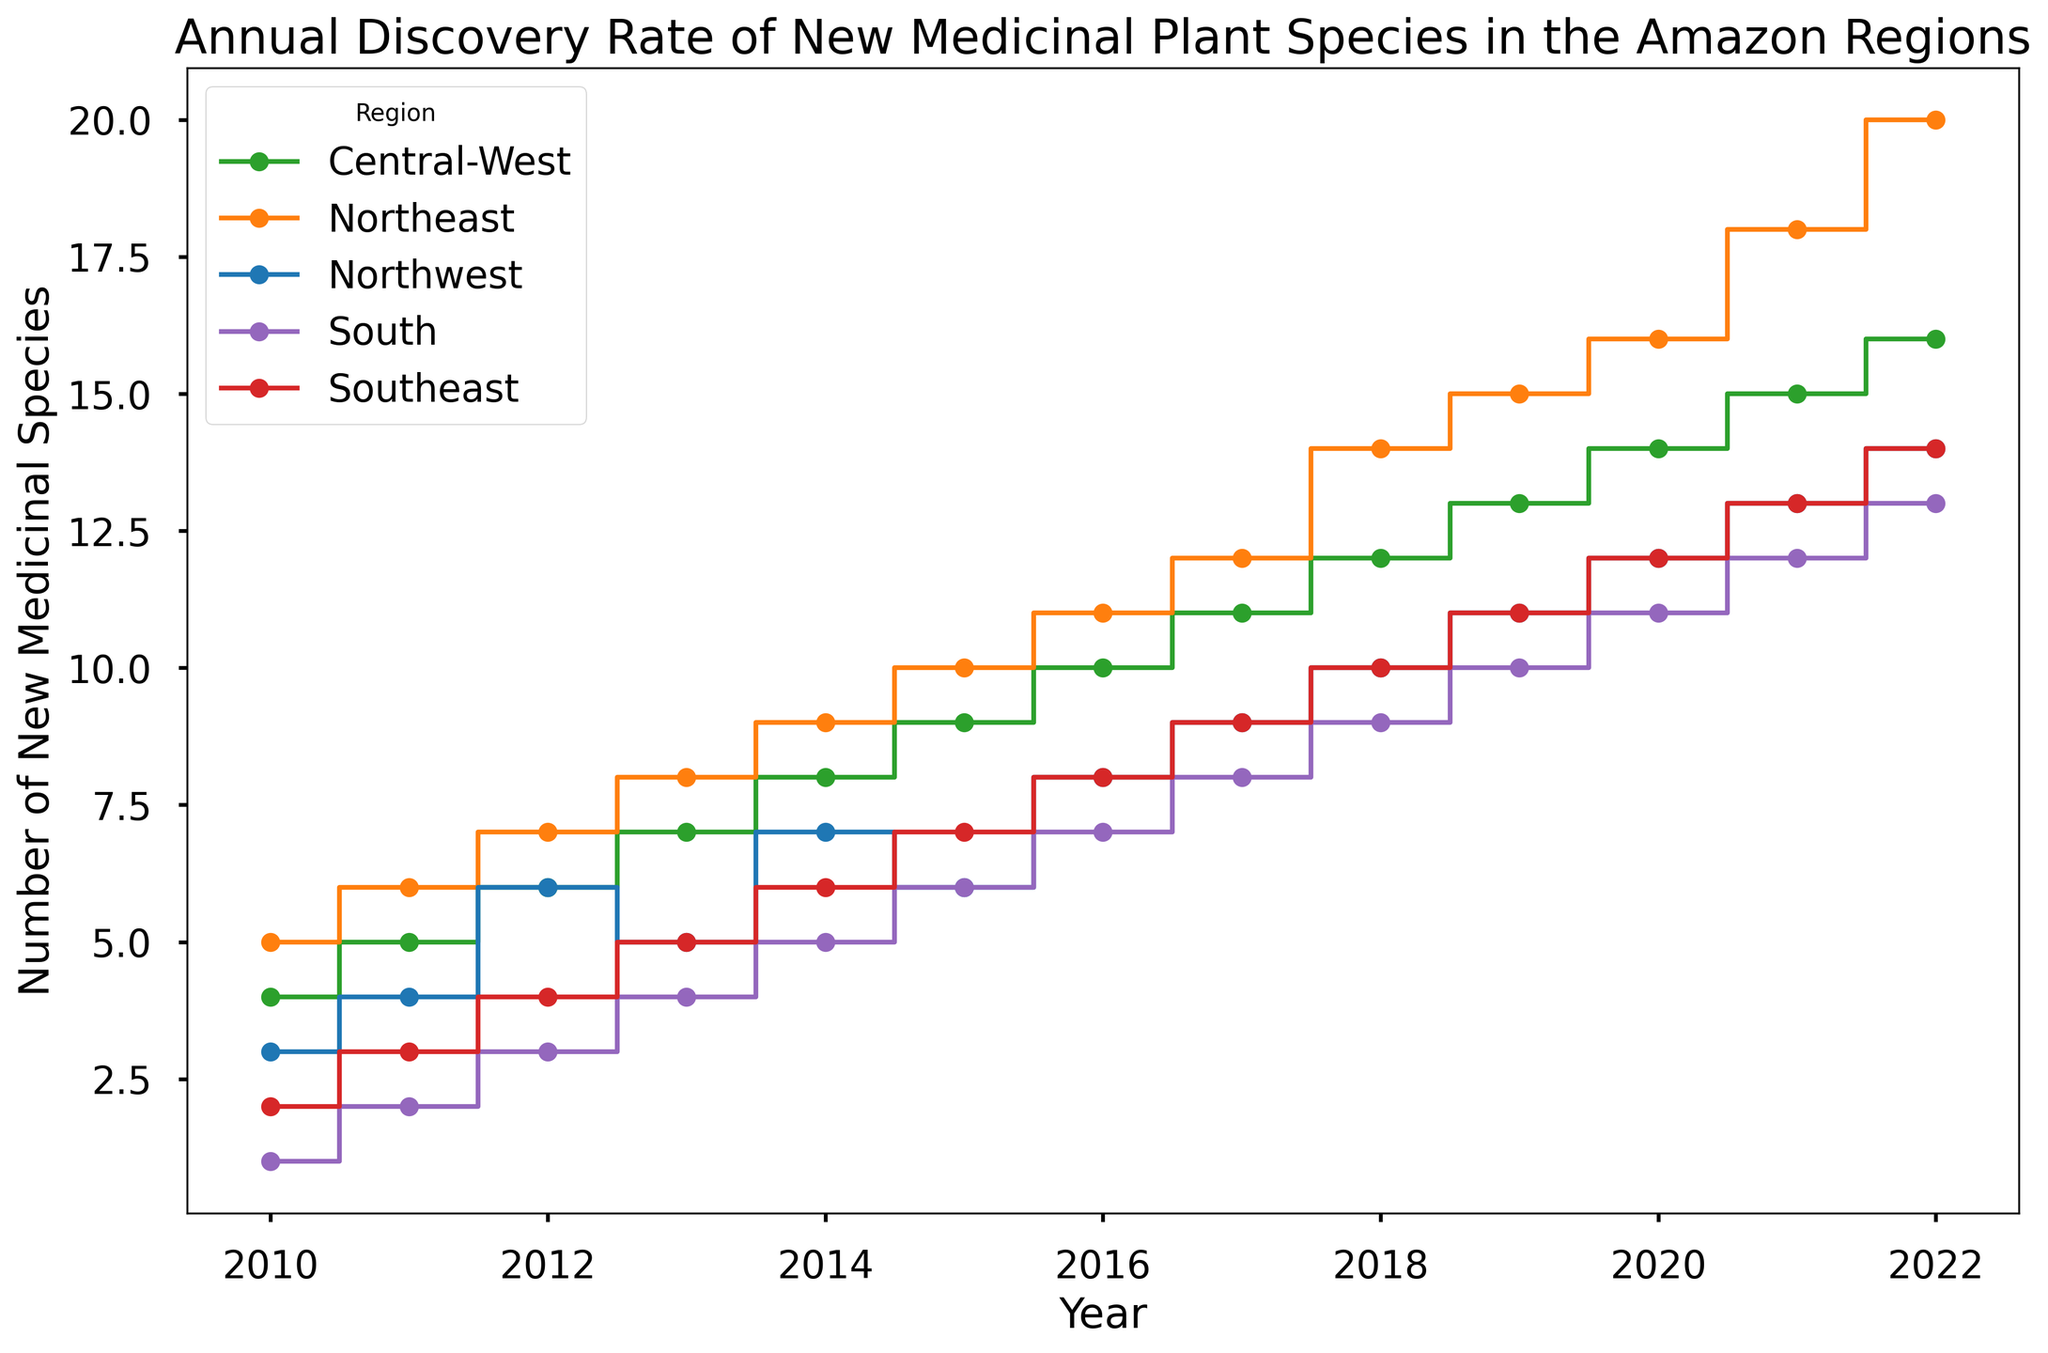Which region had the highest annual discovery rate of new medicinal plant species in 2022? Look at the end of the figure for the year 2022 and compare the heights of the steps for all regions. The Northeast has the highest value.
Answer: Northeast How did the discovery rate in the Northwest region change from 2010 to 2013? Check the figure and see how the steps move for the Northwest from 2010 to 2013. It increased continuously from 3 in 2010 to 5 in 2013.
Answer: Increased Which two regions had equal numbers of new medicinal species discovered in 2016? Locate the steps corresponding to the year 2016 for all regions and find where two regions have steps of the same height. Both Southeast and South have 8 new medicinal species discovered.
Answer: Southeast and South In which year did the Central-West region first surpass Southeast in annual discovery rates? Track the steps for both Central-West and Southeast over the years and identify the first year when Central-West's step is higher than Southeast. It happens in 2013 when Central-West has 7 while Southeast has 5.
Answer: 2013 Average the number of new medicinal species discovered from 2010 to 2012 for the Northeast region. Sum up the values for Northeast from 2010 to 2012 (5 + 6 + 7 = 18) and divide by the number of years (3). The average is 18/3.
Answer: 6 Between 2010 and 2022, in which years did the South region's annual discovery rate increase by more than one species compared to the previous year? Look at the year-to-year step changes for the South region and find where the increase is more than 1. This occurs in 2015 (4 to 6), 2018 (7 to 9), and 2022 (12 to 13).
Answer: 2015, 2018, 2022 Compare the slopes in the Northeast and Southeast regions from 2015 to 2020. Which region had a steeper increase? Calculate the rate of increase: In Northeast (10 to 16, increase of 6) and in Southeast (7 to 12, increase of 5). Since the comparison period (2015-2020) is the same, the region with a larger increase has a steeper slope.
Answer: Northeast What's the total number of new medicinal species discovered in the Amazon regions in 2017? Sum the values for all regions in 2017: Northwest (9) + Northeast (12) + Central-West (11) + Southeast (9) + South (8) = 49.
Answer: 49 Identify the year with the highest increase in new medicinal species discoveries for the Central-West region compared to the previous year. Calculate the year-to-year differences and find the maximum for the Central-West: The largest increase occurs in 2018 (12 - 11 = +1) from 2017 to 2018.
Answer: 2018 